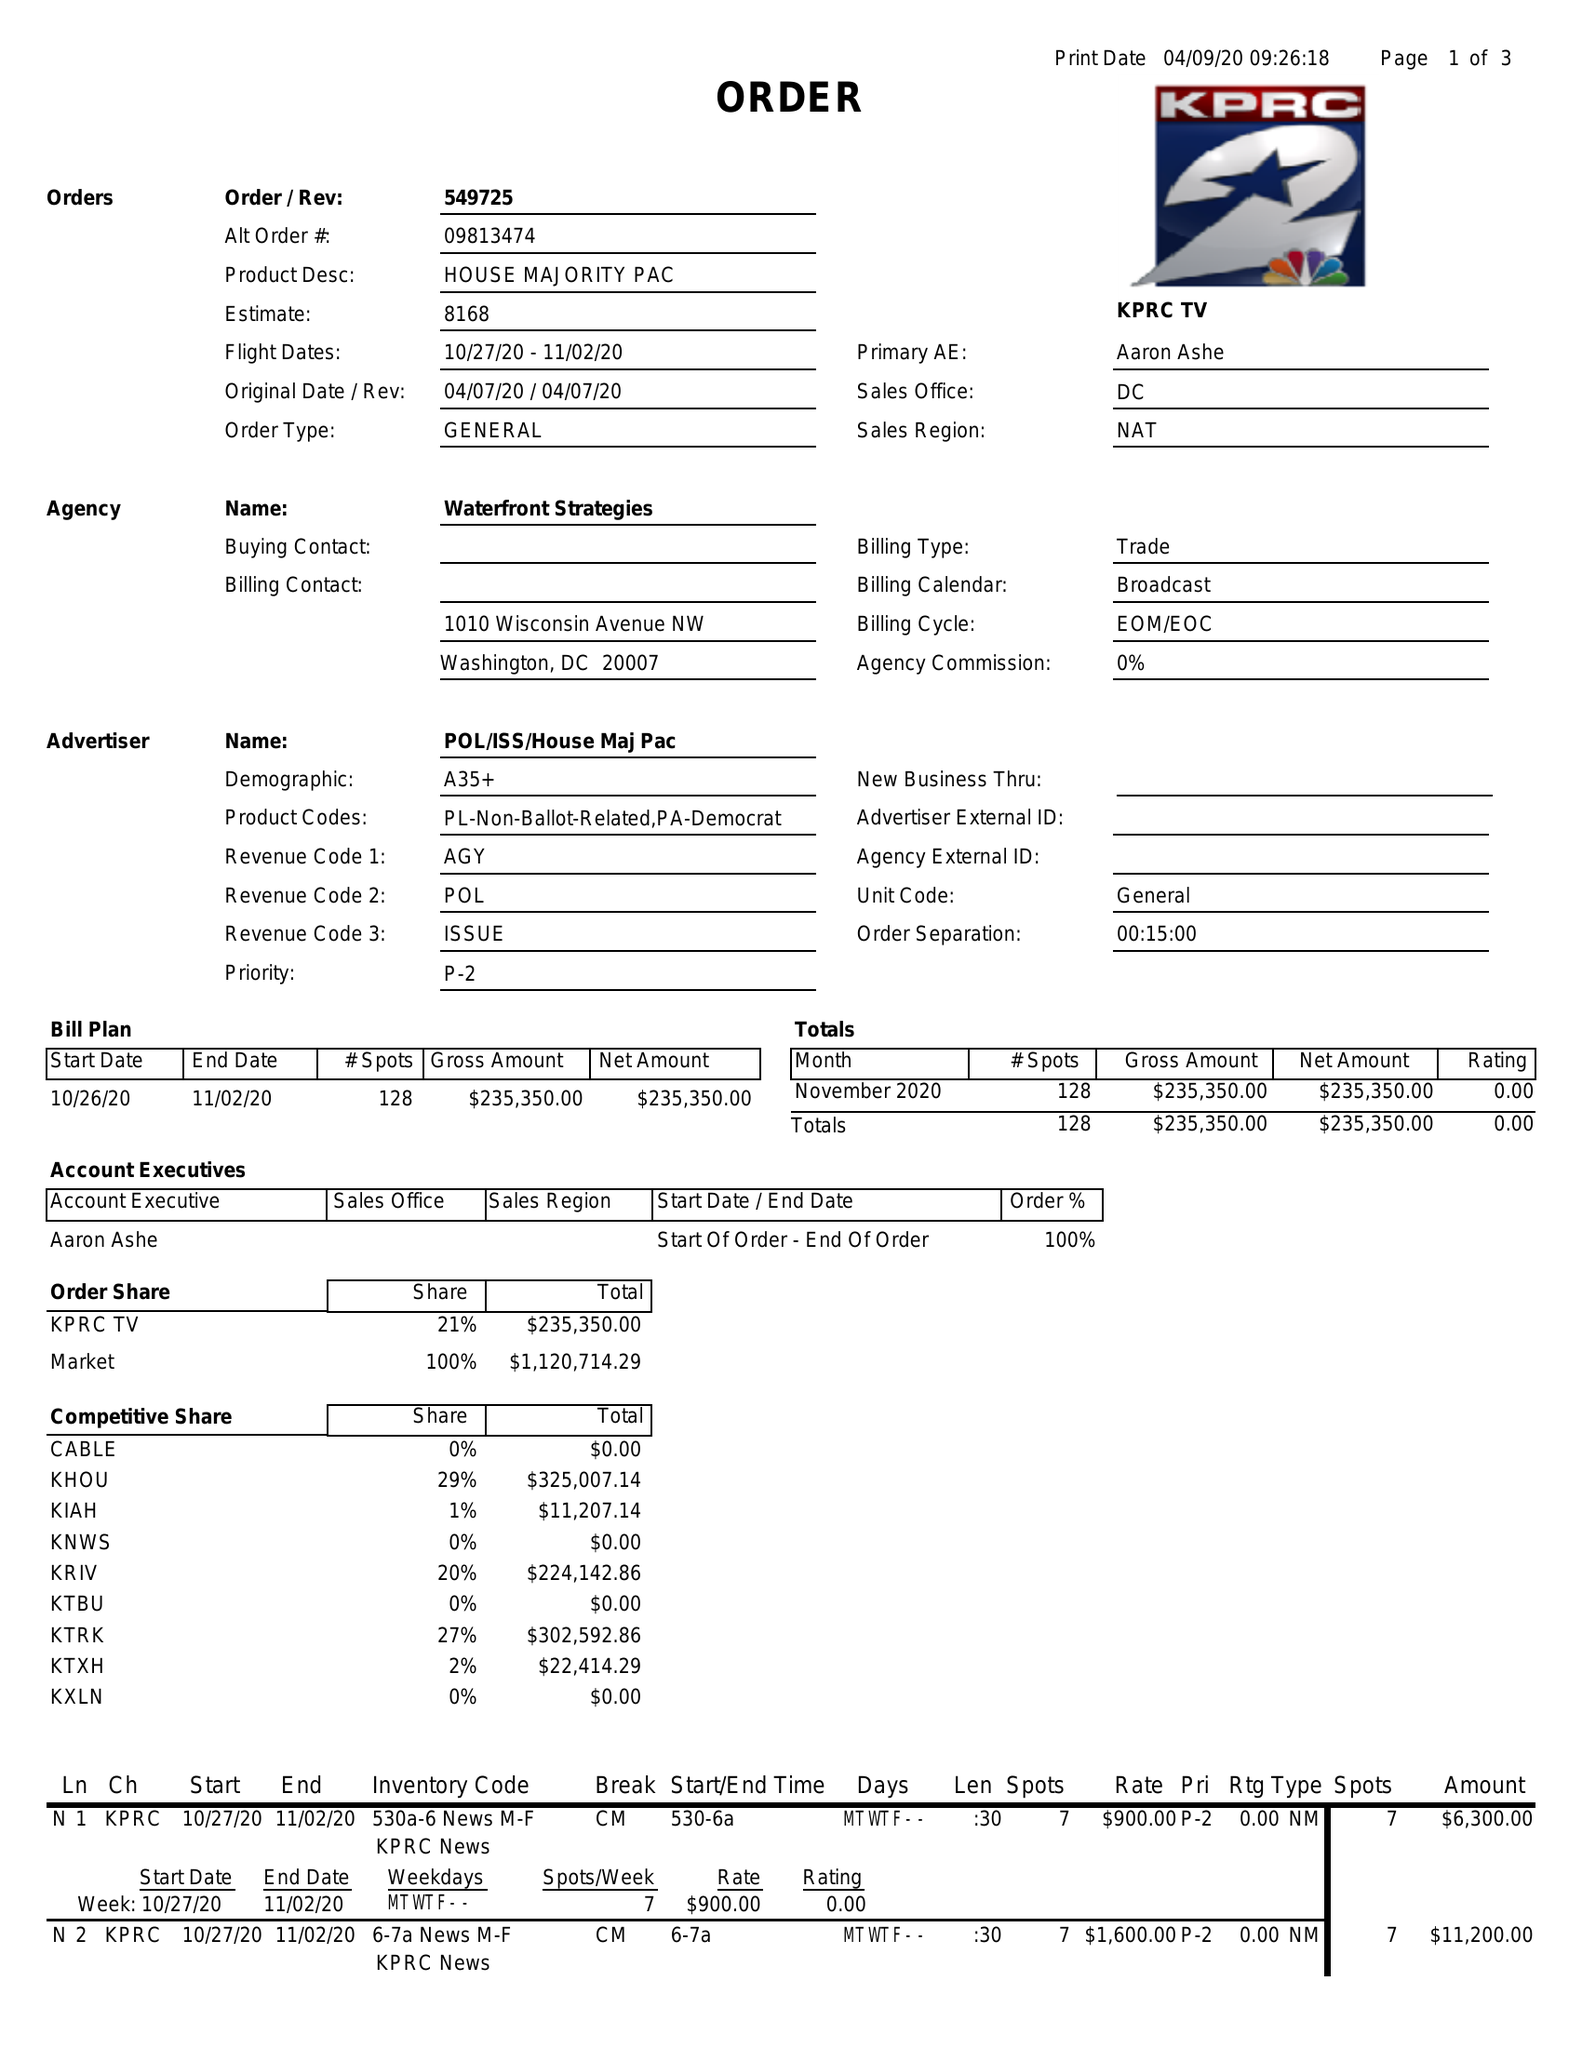What is the value for the contract_num?
Answer the question using a single word or phrase. 549725 